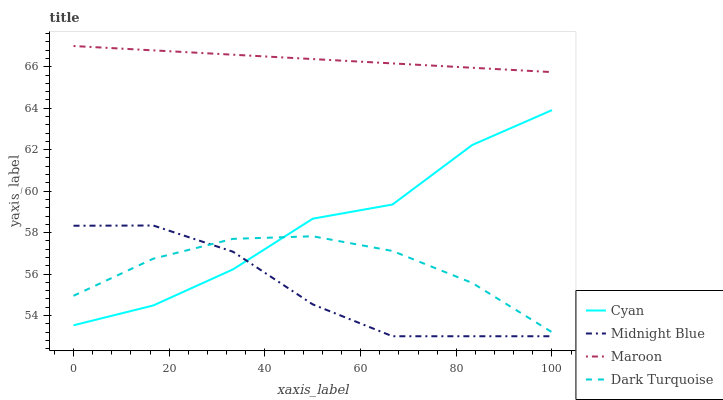Does Midnight Blue have the minimum area under the curve?
Answer yes or no. Yes. Does Maroon have the maximum area under the curve?
Answer yes or no. Yes. Does Maroon have the minimum area under the curve?
Answer yes or no. No. Does Midnight Blue have the maximum area under the curve?
Answer yes or no. No. Is Maroon the smoothest?
Answer yes or no. Yes. Is Cyan the roughest?
Answer yes or no. Yes. Is Midnight Blue the smoothest?
Answer yes or no. No. Is Midnight Blue the roughest?
Answer yes or no. No. Does Midnight Blue have the lowest value?
Answer yes or no. Yes. Does Maroon have the lowest value?
Answer yes or no. No. Does Maroon have the highest value?
Answer yes or no. Yes. Does Midnight Blue have the highest value?
Answer yes or no. No. Is Midnight Blue less than Maroon?
Answer yes or no. Yes. Is Maroon greater than Cyan?
Answer yes or no. Yes. Does Cyan intersect Dark Turquoise?
Answer yes or no. Yes. Is Cyan less than Dark Turquoise?
Answer yes or no. No. Is Cyan greater than Dark Turquoise?
Answer yes or no. No. Does Midnight Blue intersect Maroon?
Answer yes or no. No. 